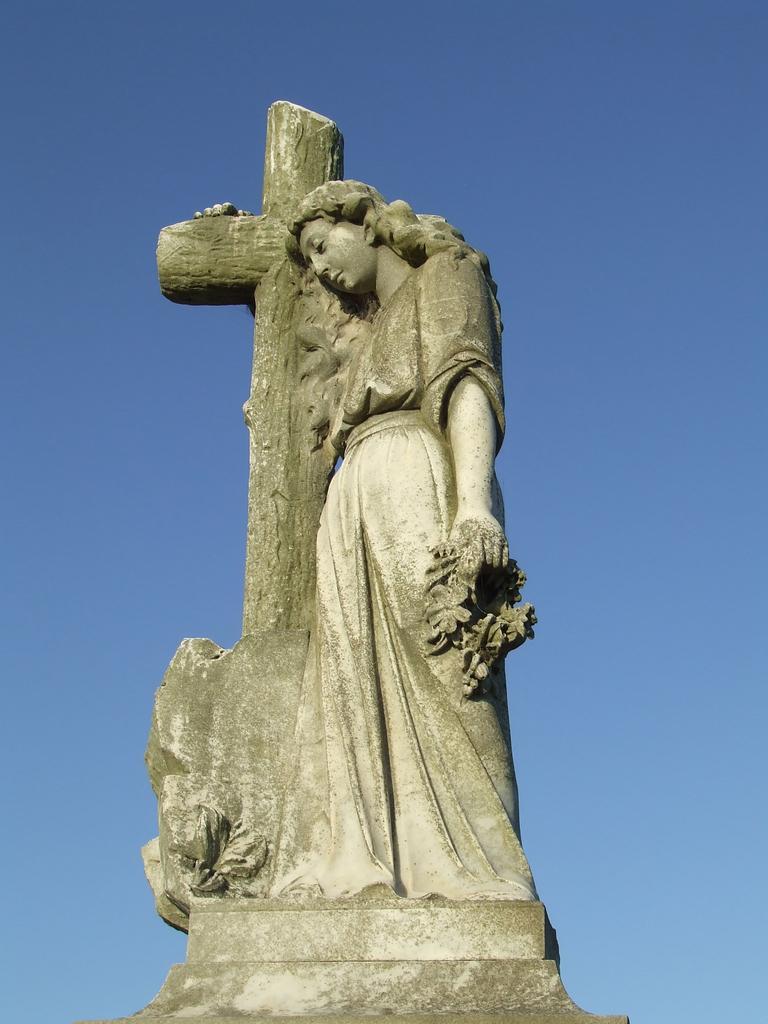Can you describe this image briefly? In this picture I can see a statue of a human and I can see a blue sky in the background. 